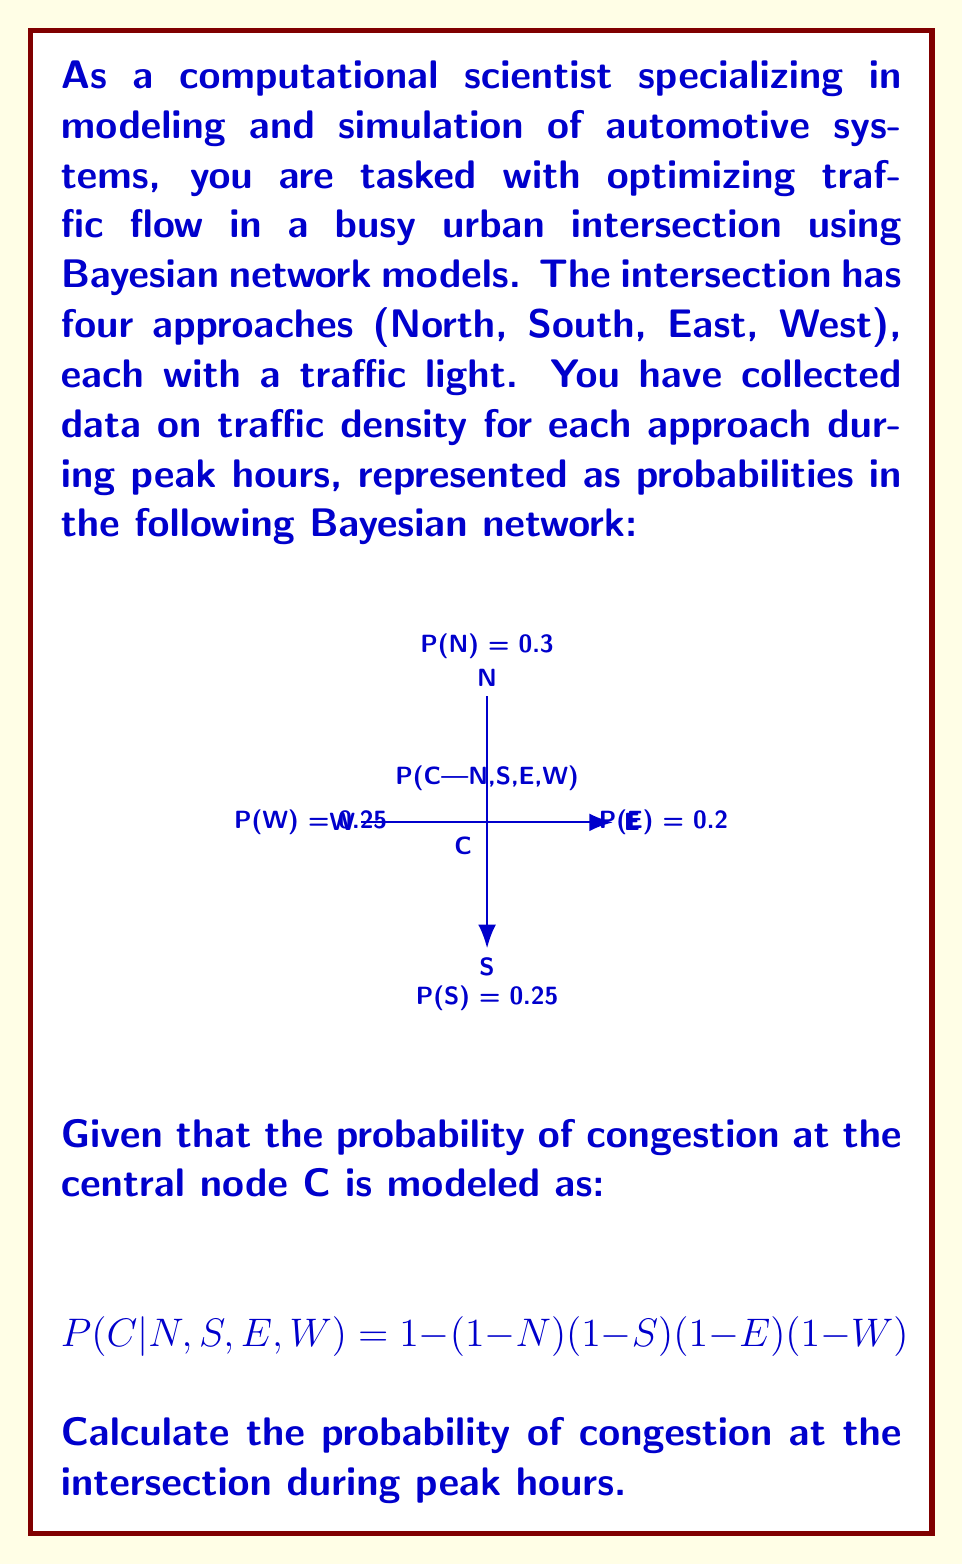Teach me how to tackle this problem. To solve this problem, we'll use the law of total probability and the given Bayesian network model. Let's break it down step by step:

1) First, we need to calculate P(C) using the law of total probability:

   $$P(C) = \sum_{N,S,E,W} P(C|N,S,E,W) \cdot P(N) \cdot P(S) \cdot P(E) \cdot P(W)$$

2) We're given P(N) = 0.3, P(S) = 0.25, P(E) = 0.2, and P(W) = 0.25.

3) We need to consider all possible combinations of traffic presence or absence in each direction. There are 2^4 = 16 combinations.

4) For each combination, we calculate P(C|N,S,E,W) using the given formula:

   $$P(C|N,S,E,W) = 1 - (1-N)(1-S)(1-E)(1-W)$$

5) Let's calculate a few examples:

   For no traffic in any direction (probability = 0.7 * 0.75 * 0.8 * 0.75):
   $$P(C|0,0,0,0) = 1 - (1-0)(1-0)(1-0)(1-0) = 0$$

   For traffic in all directions (probability = 0.3 * 0.25 * 0.2 * 0.25):
   $$P(C|1,1,1,1) = 1 - (1-1)(1-1)(1-1)(1-1) = 1$$

6) We continue this process for all 16 combinations and sum the results.

7) After calculating all combinations, we get:

   $$P(C) \approx 0.6499$$

This value represents the probability of congestion at the intersection during peak hours.
Answer: 0.6499 